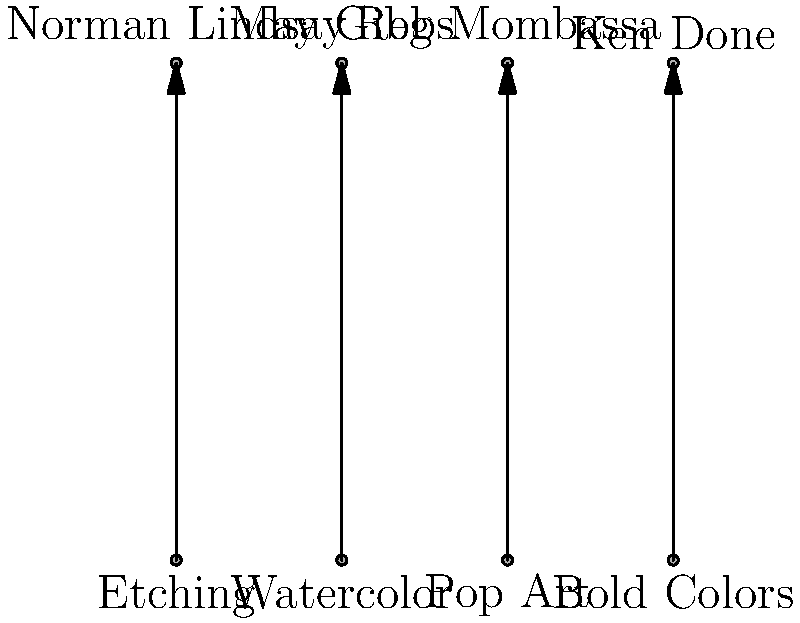Match the Australian commercial artists to their signature illustration techniques based on the given diagram. To match the Australian commercial artists to their signature illustration techniques, we need to consider each artist's distinct style:

1. Norman Lindsay: Known for his intricate and often controversial etchings, which frequently featured mythological and allegorical themes. His technique aligns with "Etching".

2. May Gibbs: Famous for her whimsical illustrations of Australian flora and fauna, particularly in children's books. She primarily used watercolors for her delicate and naturalistic style. This matches with "Watercolor".

3. Reg Mombassa: Recognized for his surreal and humorous designs, particularly for the clothing brand Mambo. His style is characterized by bold graphics and satirical themes, fitting the "Pop Art" category.

4. Ken Done: Celebrated for his vibrant, colorful depictions of Australian landscapes and icons. His work is instantly recognizable for its use of "Bold Colors".

Therefore, the correct matching is:
Norman Lindsay - Etching
May Gibbs - Watercolor
Reg Mombassa - Pop Art
Ken Done - Bold Colors
Answer: Norman Lindsay: Etching; May Gibbs: Watercolor; Reg Mombassa: Pop Art; Ken Done: Bold Colors 